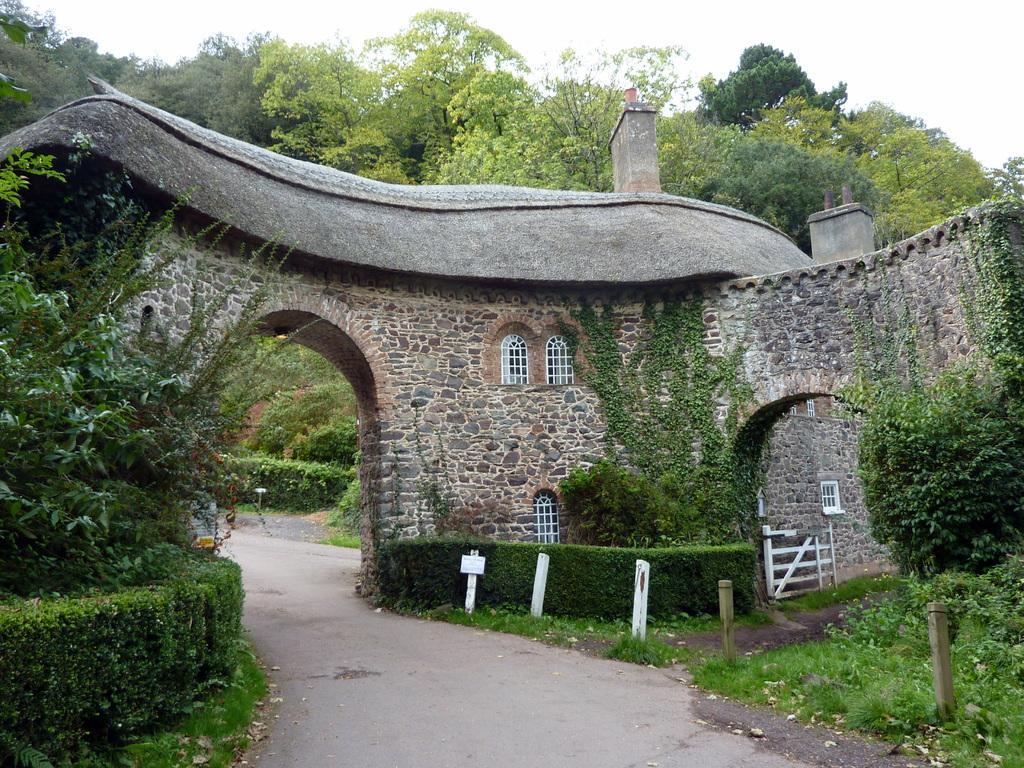Please provide a concise description of this image. In this image there is a road, on either side of the road there are plants, in the background there is a monument, trees and the sky. 